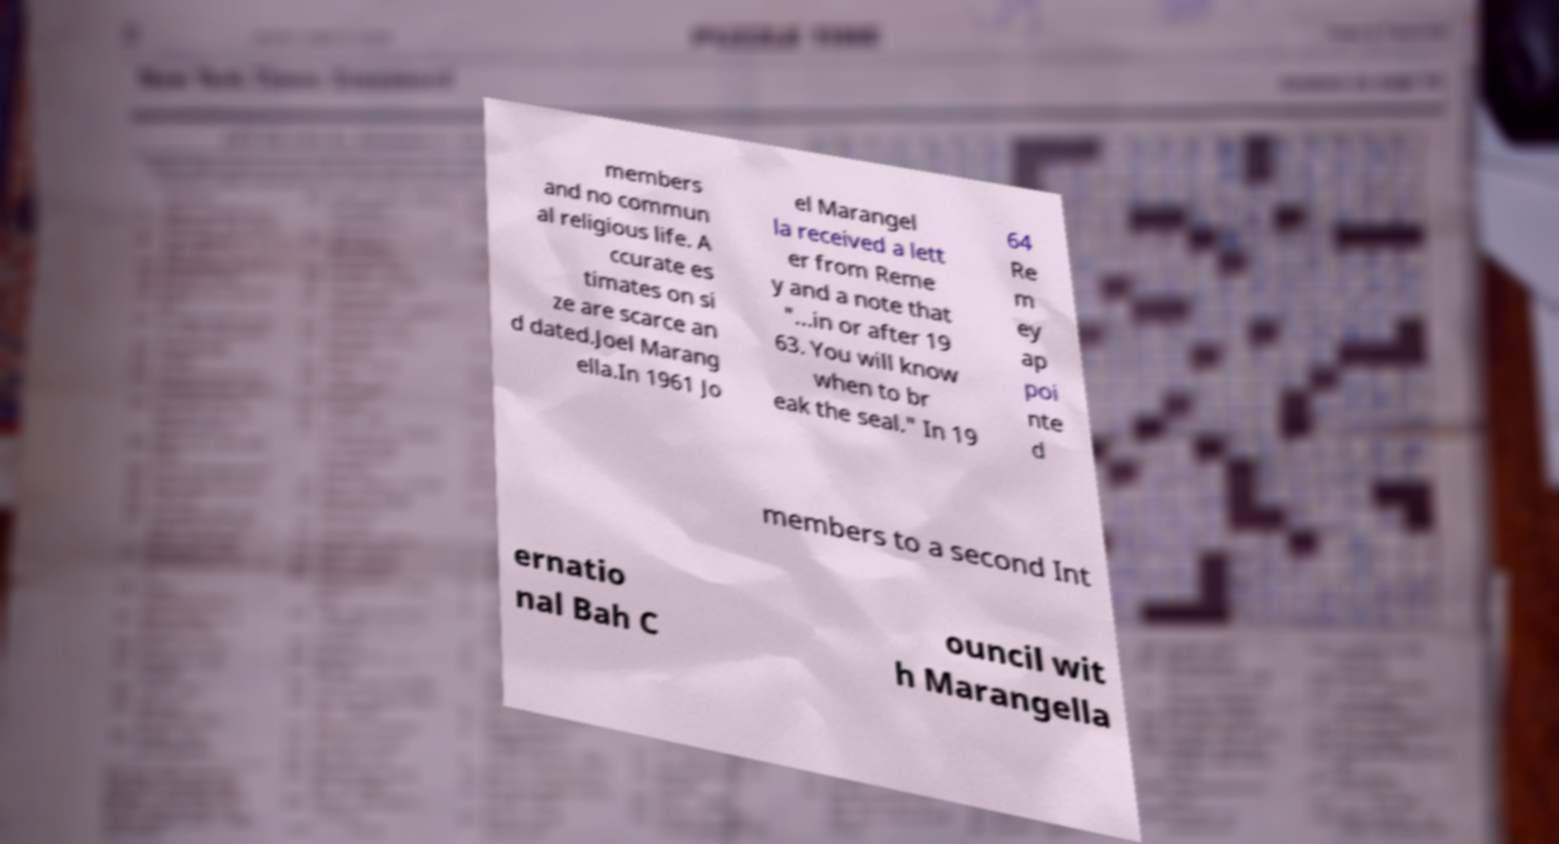Could you extract and type out the text from this image? members and no commun al religious life. A ccurate es timates on si ze are scarce an d dated.Joel Marang ella.In 1961 Jo el Marangel la received a lett er from Reme y and a note that "...in or after 19 63. You will know when to br eak the seal." In 19 64 Re m ey ap poi nte d members to a second Int ernatio nal Bah C ouncil wit h Marangella 